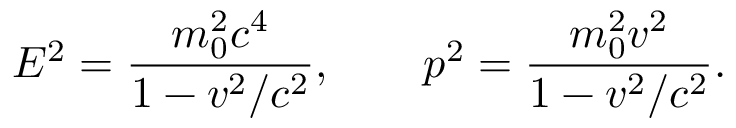<formula> <loc_0><loc_0><loc_500><loc_500>E ^ { 2 } = { \frac { m _ { 0 } ^ { 2 } c ^ { 4 } } { 1 - v ^ { 2 } / c ^ { 2 } } } , \quad p ^ { 2 } = { \frac { m _ { 0 } ^ { 2 } v ^ { 2 } } { 1 - v ^ { 2 } / c ^ { 2 } } } .</formula> 